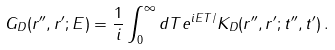<formula> <loc_0><loc_0><loc_500><loc_500>G _ { D } ( { r ^ { \prime \prime } } , { r ^ { \prime } } ; E ) = \frac { 1 } { i } \int _ { 0 } ^ { \infty } d T e ^ { i E T / } K _ { D } ( { r ^ { \prime \prime } } , { r ^ { \prime } } ; t ^ { \prime \prime } , t ^ { \prime } ) \, .</formula> 